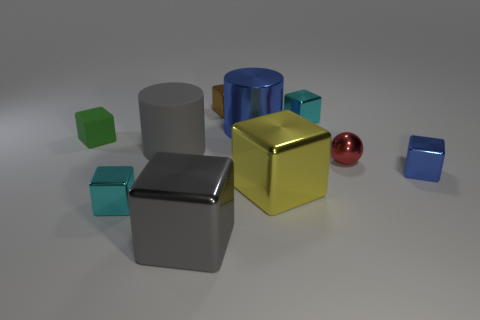Do the red metal ball and the green cube have the same size?
Offer a terse response. Yes. There is a blue thing to the left of the cyan metal block that is behind the yellow shiny block; is there a small blue metal thing that is behind it?
Your answer should be compact. No. There is a large gray object that is the same shape as the large blue metallic thing; what is it made of?
Keep it short and to the point. Rubber. What is the color of the metallic cube that is right of the red sphere?
Ensure brevity in your answer.  Blue. The yellow metallic thing has what size?
Your answer should be very brief. Large. Do the green matte block and the metallic object that is to the left of the large rubber cylinder have the same size?
Offer a very short reply. Yes. There is a tiny cube that is left of the cyan shiny cube in front of the cyan metal thing that is to the right of the large blue metal cylinder; what is its color?
Your response must be concise. Green. Is the material of the tiny cyan thing that is in front of the metallic sphere the same as the gray cube?
Give a very brief answer. Yes. What number of other objects are the same material as the small red thing?
Ensure brevity in your answer.  7. What material is the gray cylinder that is the same size as the yellow thing?
Provide a succinct answer. Rubber. 